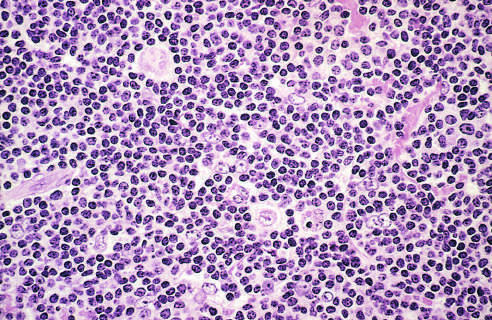do numerous mature-looking lymphocytes surround scattered, large, pale-staining lymphocytic and histiocytic variants (popcorn cells)?
Answer the question using a single word or phrase. Yes 